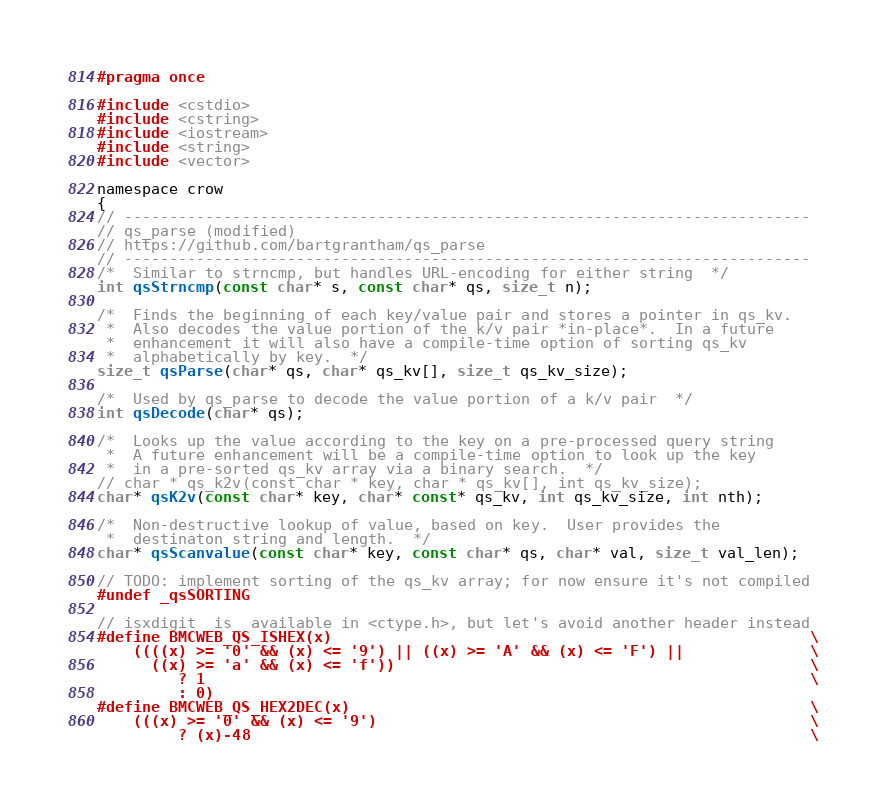<code> <loc_0><loc_0><loc_500><loc_500><_C_>#pragma once

#include <cstdio>
#include <cstring>
#include <iostream>
#include <string>
#include <vector>

namespace crow
{
// ----------------------------------------------------------------------------
// qs_parse (modified)
// https://github.com/bartgrantham/qs_parse
// ----------------------------------------------------------------------------
/*  Similar to strncmp, but handles URL-encoding for either string  */
int qsStrncmp(const char* s, const char* qs, size_t n);

/*  Finds the beginning of each key/value pair and stores a pointer in qs_kv.
 *  Also decodes the value portion of the k/v pair *in-place*.  In a future
 *  enhancement it will also have a compile-time option of sorting qs_kv
 *  alphabetically by key.  */
size_t qsParse(char* qs, char* qs_kv[], size_t qs_kv_size);

/*  Used by qs_parse to decode the value portion of a k/v pair  */
int qsDecode(char* qs);

/*  Looks up the value according to the key on a pre-processed query string
 *  A future enhancement will be a compile-time option to look up the key
 *  in a pre-sorted qs_kv array via a binary search.  */
// char * qs_k2v(const char * key, char * qs_kv[], int qs_kv_size);
char* qsK2v(const char* key, char* const* qs_kv, int qs_kv_size, int nth);

/*  Non-destructive lookup of value, based on key.  User provides the
 *  destinaton string and length.  */
char* qsScanvalue(const char* key, const char* qs, char* val, size_t val_len);

// TODO: implement sorting of the qs_kv array; for now ensure it's not compiled
#undef _qsSORTING

// isxdigit _is_ available in <ctype.h>, but let's avoid another header instead
#define BMCWEB_QS_ISHEX(x)                                                     \
    ((((x) >= '0' && (x) <= '9') || ((x) >= 'A' && (x) <= 'F') ||              \
      ((x) >= 'a' && (x) <= 'f'))                                              \
         ? 1                                                                   \
         : 0)
#define BMCWEB_QS_HEX2DEC(x)                                                   \
    (((x) >= '0' && (x) <= '9')                                                \
         ? (x)-48                                                              \</code> 